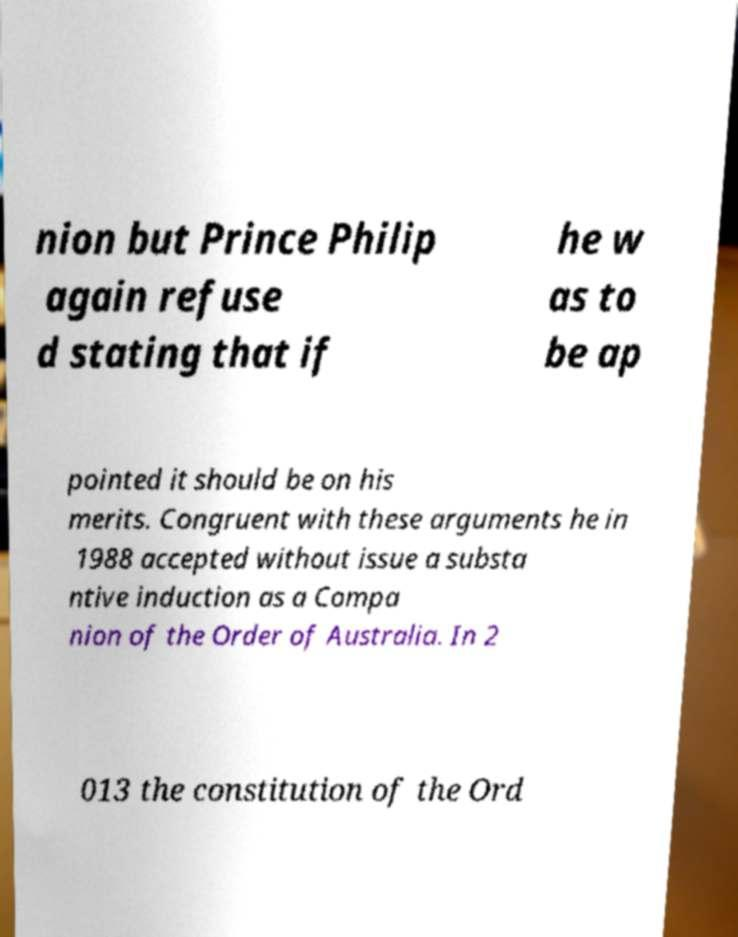I need the written content from this picture converted into text. Can you do that? nion but Prince Philip again refuse d stating that if he w as to be ap pointed it should be on his merits. Congruent with these arguments he in 1988 accepted without issue a substa ntive induction as a Compa nion of the Order of Australia. In 2 013 the constitution of the Ord 